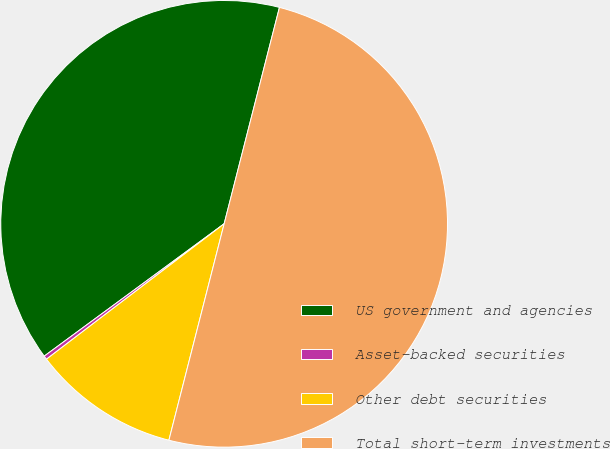Convert chart to OTSL. <chart><loc_0><loc_0><loc_500><loc_500><pie_chart><fcel>US government and agencies<fcel>Asset-backed securities<fcel>Other debt securities<fcel>Total short-term investments<nl><fcel>39.08%<fcel>0.27%<fcel>10.66%<fcel>50.0%<nl></chart> 